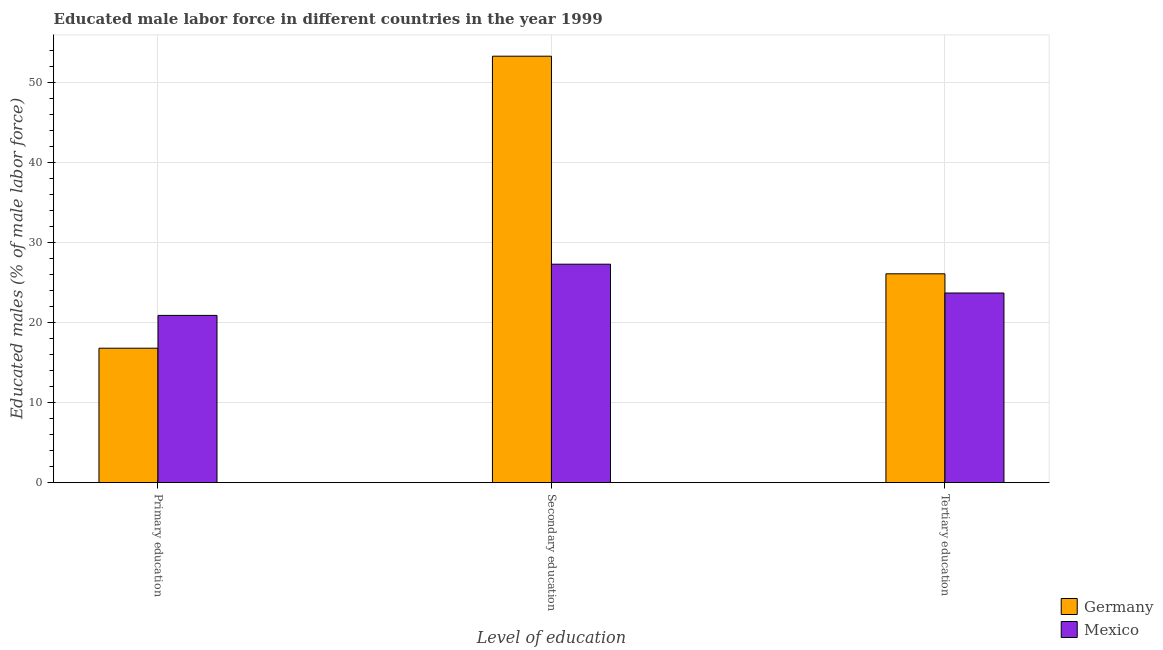How many different coloured bars are there?
Provide a short and direct response. 2. Are the number of bars on each tick of the X-axis equal?
Provide a succinct answer. Yes. How many bars are there on the 3rd tick from the left?
Ensure brevity in your answer.  2. What is the label of the 1st group of bars from the left?
Offer a terse response. Primary education. What is the percentage of male labor force who received secondary education in Germany?
Ensure brevity in your answer.  53.3. Across all countries, what is the maximum percentage of male labor force who received secondary education?
Make the answer very short. 53.3. Across all countries, what is the minimum percentage of male labor force who received tertiary education?
Keep it short and to the point. 23.7. In which country was the percentage of male labor force who received tertiary education maximum?
Make the answer very short. Germany. What is the total percentage of male labor force who received primary education in the graph?
Offer a very short reply. 37.7. What is the difference between the percentage of male labor force who received tertiary education in Mexico and that in Germany?
Keep it short and to the point. -2.4. What is the average percentage of male labor force who received secondary education per country?
Provide a succinct answer. 40.3. What is the difference between the percentage of male labor force who received tertiary education and percentage of male labor force who received primary education in Germany?
Provide a short and direct response. 9.3. In how many countries, is the percentage of male labor force who received secondary education greater than 48 %?
Keep it short and to the point. 1. What is the ratio of the percentage of male labor force who received secondary education in Mexico to that in Germany?
Give a very brief answer. 0.51. Is the percentage of male labor force who received primary education in Germany less than that in Mexico?
Provide a succinct answer. Yes. Is the difference between the percentage of male labor force who received primary education in Germany and Mexico greater than the difference between the percentage of male labor force who received tertiary education in Germany and Mexico?
Your answer should be compact. No. What is the difference between the highest and the second highest percentage of male labor force who received tertiary education?
Offer a very short reply. 2.4. What is the difference between the highest and the lowest percentage of male labor force who received tertiary education?
Make the answer very short. 2.4. In how many countries, is the percentage of male labor force who received tertiary education greater than the average percentage of male labor force who received tertiary education taken over all countries?
Give a very brief answer. 1. What does the 1st bar from the left in Primary education represents?
Your response must be concise. Germany. What does the 2nd bar from the right in Primary education represents?
Ensure brevity in your answer.  Germany. How many bars are there?
Provide a succinct answer. 6. Are the values on the major ticks of Y-axis written in scientific E-notation?
Your answer should be compact. No. Does the graph contain grids?
Keep it short and to the point. Yes. What is the title of the graph?
Offer a very short reply. Educated male labor force in different countries in the year 1999. Does "Hong Kong" appear as one of the legend labels in the graph?
Give a very brief answer. No. What is the label or title of the X-axis?
Ensure brevity in your answer.  Level of education. What is the label or title of the Y-axis?
Your answer should be very brief. Educated males (% of male labor force). What is the Educated males (% of male labor force) of Germany in Primary education?
Provide a succinct answer. 16.8. What is the Educated males (% of male labor force) of Mexico in Primary education?
Give a very brief answer. 20.9. What is the Educated males (% of male labor force) of Germany in Secondary education?
Keep it short and to the point. 53.3. What is the Educated males (% of male labor force) of Mexico in Secondary education?
Offer a very short reply. 27.3. What is the Educated males (% of male labor force) in Germany in Tertiary education?
Provide a succinct answer. 26.1. What is the Educated males (% of male labor force) of Mexico in Tertiary education?
Your answer should be compact. 23.7. Across all Level of education, what is the maximum Educated males (% of male labor force) in Germany?
Your response must be concise. 53.3. Across all Level of education, what is the maximum Educated males (% of male labor force) in Mexico?
Your answer should be very brief. 27.3. Across all Level of education, what is the minimum Educated males (% of male labor force) of Germany?
Offer a very short reply. 16.8. Across all Level of education, what is the minimum Educated males (% of male labor force) in Mexico?
Keep it short and to the point. 20.9. What is the total Educated males (% of male labor force) of Germany in the graph?
Keep it short and to the point. 96.2. What is the total Educated males (% of male labor force) of Mexico in the graph?
Make the answer very short. 71.9. What is the difference between the Educated males (% of male labor force) of Germany in Primary education and that in Secondary education?
Provide a short and direct response. -36.5. What is the difference between the Educated males (% of male labor force) of Mexico in Primary education and that in Secondary education?
Provide a succinct answer. -6.4. What is the difference between the Educated males (% of male labor force) in Germany in Primary education and that in Tertiary education?
Your answer should be very brief. -9.3. What is the difference between the Educated males (% of male labor force) of Mexico in Primary education and that in Tertiary education?
Offer a very short reply. -2.8. What is the difference between the Educated males (% of male labor force) in Germany in Secondary education and that in Tertiary education?
Ensure brevity in your answer.  27.2. What is the difference between the Educated males (% of male labor force) of Germany in Primary education and the Educated males (% of male labor force) of Mexico in Secondary education?
Keep it short and to the point. -10.5. What is the difference between the Educated males (% of male labor force) of Germany in Primary education and the Educated males (% of male labor force) of Mexico in Tertiary education?
Your response must be concise. -6.9. What is the difference between the Educated males (% of male labor force) of Germany in Secondary education and the Educated males (% of male labor force) of Mexico in Tertiary education?
Give a very brief answer. 29.6. What is the average Educated males (% of male labor force) of Germany per Level of education?
Provide a succinct answer. 32.07. What is the average Educated males (% of male labor force) of Mexico per Level of education?
Make the answer very short. 23.97. What is the ratio of the Educated males (% of male labor force) of Germany in Primary education to that in Secondary education?
Your answer should be compact. 0.32. What is the ratio of the Educated males (% of male labor force) in Mexico in Primary education to that in Secondary education?
Give a very brief answer. 0.77. What is the ratio of the Educated males (% of male labor force) in Germany in Primary education to that in Tertiary education?
Make the answer very short. 0.64. What is the ratio of the Educated males (% of male labor force) of Mexico in Primary education to that in Tertiary education?
Keep it short and to the point. 0.88. What is the ratio of the Educated males (% of male labor force) of Germany in Secondary education to that in Tertiary education?
Provide a short and direct response. 2.04. What is the ratio of the Educated males (% of male labor force) of Mexico in Secondary education to that in Tertiary education?
Offer a terse response. 1.15. What is the difference between the highest and the second highest Educated males (% of male labor force) of Germany?
Keep it short and to the point. 27.2. What is the difference between the highest and the lowest Educated males (% of male labor force) of Germany?
Your response must be concise. 36.5. 